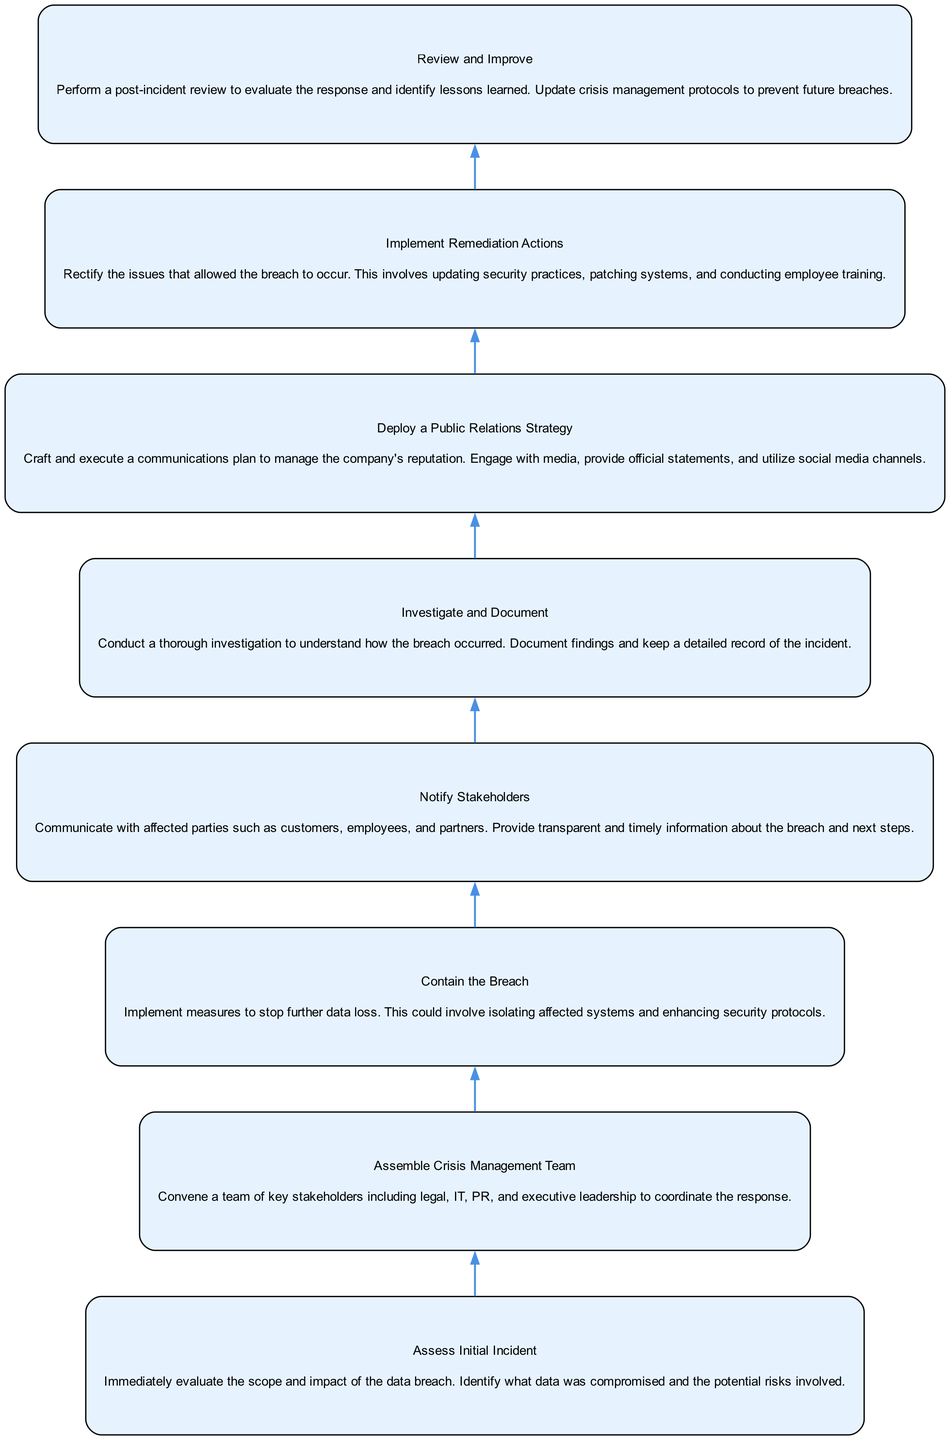What is the first step in managing a data breach? The diagram indicates that the first step is "Assess Initial Incident." This is the initial action to evaluate the scope and impact of the data breach.
Answer: Assess Initial Incident How many nodes are in the diagram? By counting the individual steps outlined, the diagram consists of eight nodes, each representing a distinct step in the crisis management protocol.
Answer: 8 What describes the action taken after "Assemble Crisis Management Team"? The next action in the flow after "Assemble Crisis Management Team" is "Contain the Breach." This shows the logical progression from forming the team to actually addressing the breach.
Answer: Contain the Breach Which node directly precedes "Notify Stakeholders"? The node that comes right before "Notify Stakeholders" is "Contain the Breach." This indicates that containment measures must be in place before notifying those affected.
Answer: Contain the Breach What is the last step in the process? The final action in the diagram is "Review and Improve." This indicates that a post-incident review is the concluding phase of the data breach management protocol.
Answer: Review and Improve What type of teams are involved in the "Assemble Crisis Management Team" step? The involved teams include legal, IT, PR, and executive leadership, as highlighted in the description. This multi-disciplinary approach ensures a comprehensive response.
Answer: Legal, IT, PR, executive leadership Which action involves rectifying security practices? The step that involves rectifying security practices is "Implement Remediation Actions." This emphasizes the need to address the vulnerabilities that led to the breach.
Answer: Implement Remediation Actions What is the purpose of "Deploy a Public Relations Strategy"? The purpose of this step is to manage the company's reputation through effective communication with media and other stakeholders about the breach.
Answer: Manage company's reputation 